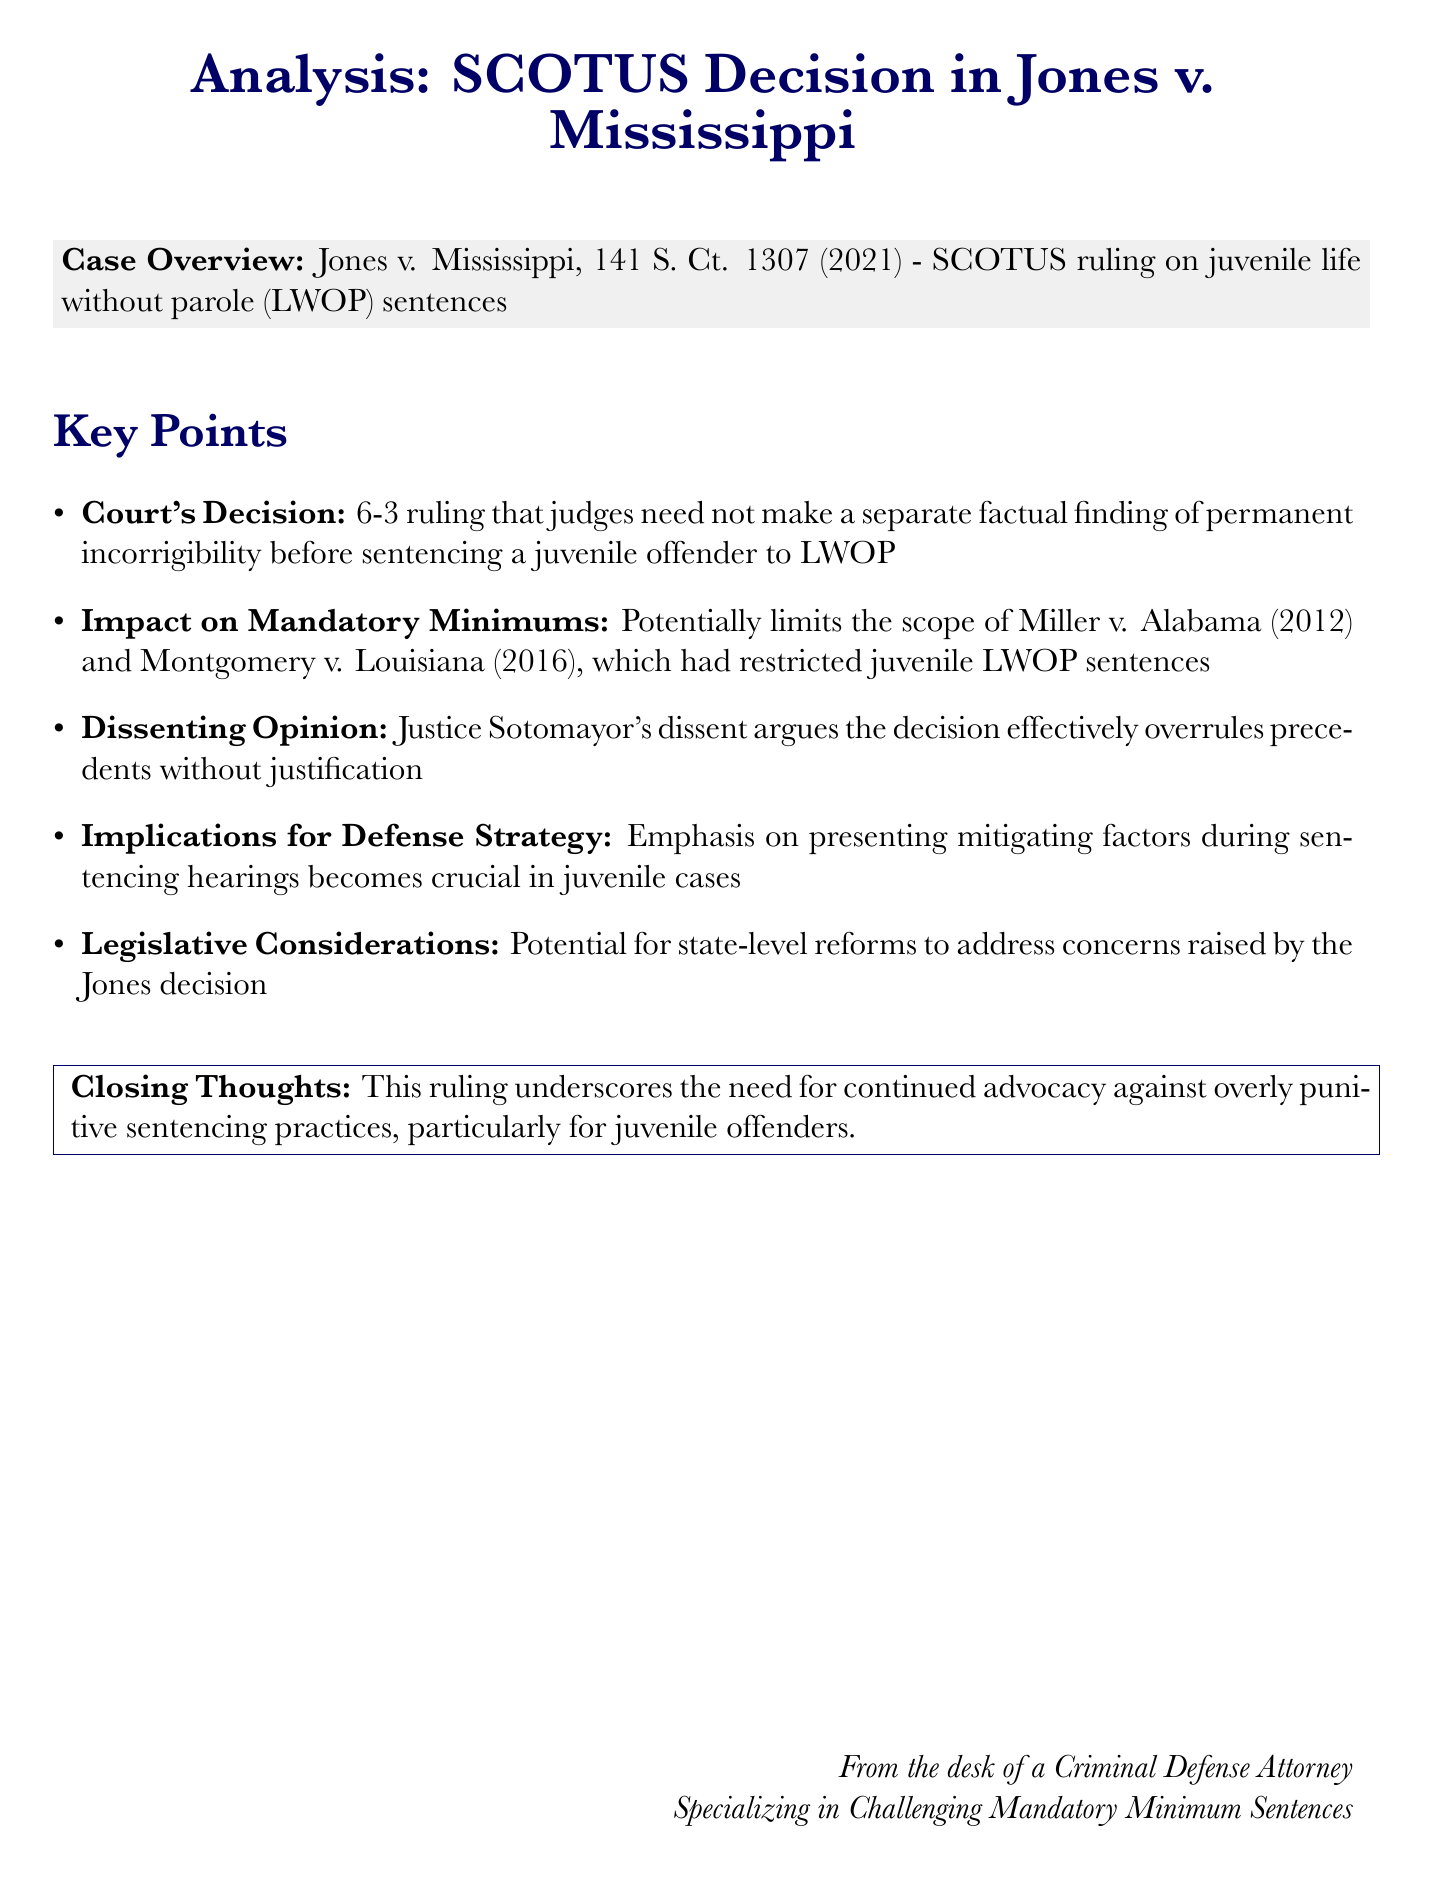What is the case name? The case discussed in the document is identified in the title section, which is Jones v. Mississippi.
Answer: Jones v. Mississippi What is the Supreme Court ruling? The document specifies the ruling as a 6-3 decision regarding juvenile life without parole sentences.
Answer: 6-3 ruling What year was the Jones v. Mississippi decision issued? The document includes the citation, which provides the year as 2021.
Answer: 2021 Who wrote the dissenting opinion? The document attributes the dissenting opinion to Justice Sotomayor.
Answer: Justice Sotomayor What is a key implication of the ruling for defense strategy? The document highlights that presenting mitigating factors becomes crucial during sentencing hearings in juvenile cases.
Answer: presenting mitigating factors Which previous cases might be limited by this ruling? The document references Miller v. Alabama and Montgomery v. Louisiana as potentially limited by the ruling.
Answer: Miller v. Alabama, Montgomery v. Louisiana What should advocates focus on after this decision? The closing thoughts emphasize advocacy against overly punitive sentencing practices, particularly for juvenile offenders.
Answer: advocacy against overly punitive sentencing practices What is the primary focus of the document? The document provides an analysis of the Supreme Court decision and its implications, specifically for mandatory minimum sentences.
Answer: Analysis of SCOTUS decision and implications for mandatory minimums 